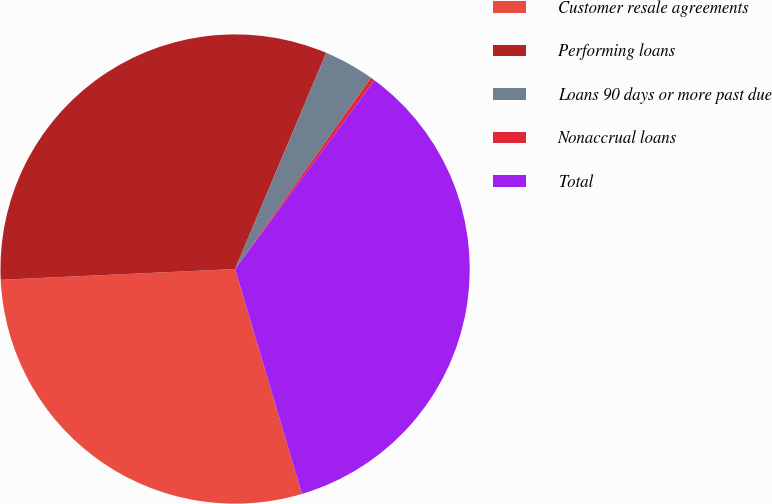<chart> <loc_0><loc_0><loc_500><loc_500><pie_chart><fcel>Customer resale agreements<fcel>Performing loans<fcel>Loans 90 days or more past due<fcel>Nonaccrual loans<fcel>Total<nl><fcel>28.87%<fcel>32.08%<fcel>3.49%<fcel>0.28%<fcel>35.28%<nl></chart> 